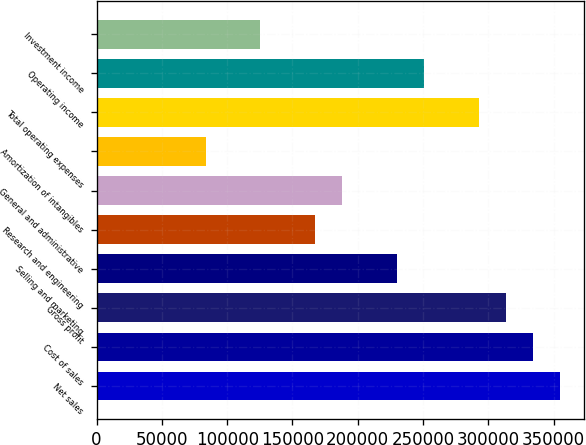Convert chart to OTSL. <chart><loc_0><loc_0><loc_500><loc_500><bar_chart><fcel>Net sales<fcel>Cost of sales<fcel>Gross profit<fcel>Selling and marketing<fcel>Research and engineering<fcel>General and administrative<fcel>Amortization of intangibles<fcel>Total operating expenses<fcel>Operating income<fcel>Investment income<nl><fcel>355150<fcel>334259<fcel>313368<fcel>229803<fcel>167130<fcel>188021<fcel>83565<fcel>292477<fcel>250694<fcel>125347<nl></chart> 